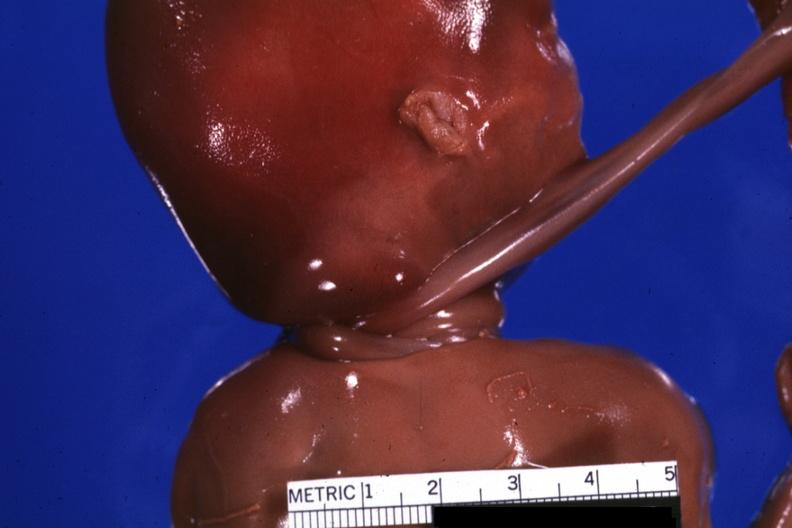s newborn cord around neck present?
Answer the question using a single word or phrase. Yes 